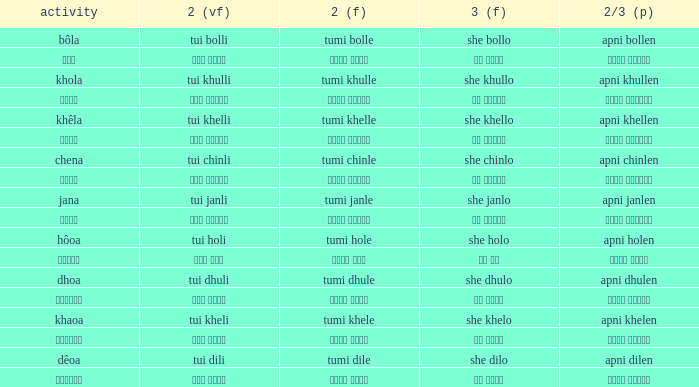What is the verb for Khola? She khullo. 